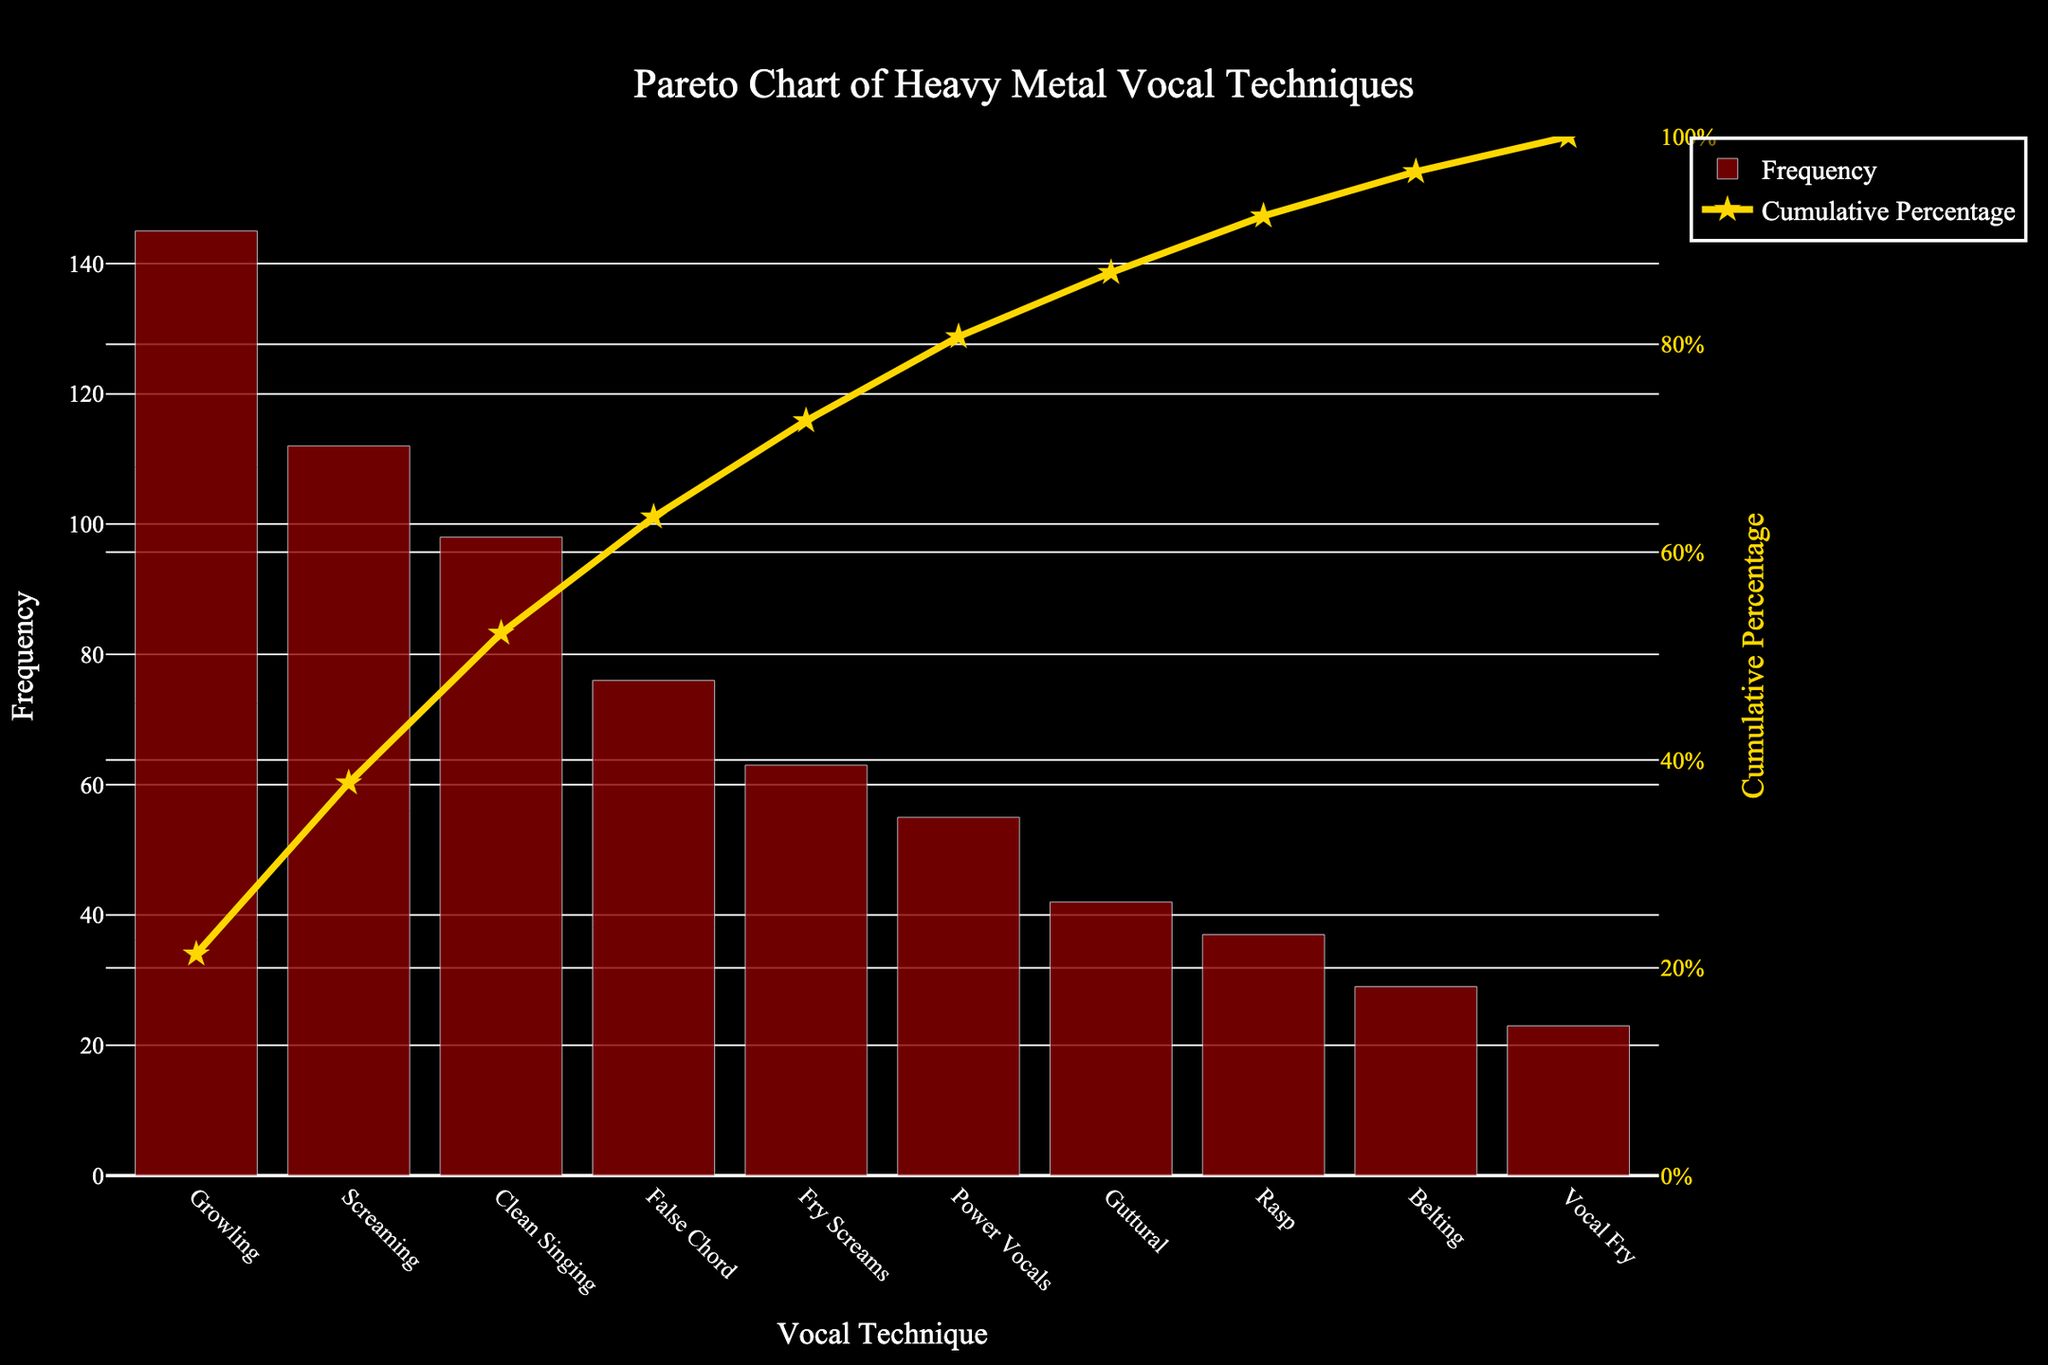What's the most frequently used vocal technique in heavy metal songs according to the chart? The bar with the highest frequency shows the Vocal Technique "Growling" at 145 occurrences, which makes it the most frequently used.
Answer: Growling What is the title of the chart? The chart title can be found at the top and reads "Pareto Chart of Heavy Metal Vocal Techniques".
Answer: Pareto Chart of Heavy Metal Vocal Techniques How many vocal techniques have a frequency higher than 100? By examining the bars, "Growling" and "Screaming" both have frequencies higher than 100 (145 and 112, respectively).
Answer: 2 Which vocal technique has the lowest frequency? The bar with the smallest height represents the "Vocal Fry" technique, with a frequency of 23.
Answer: Vocal Fry What's the cumulative percentage of the first three vocal techniques combined? Summing up the first three frequencies (145+112+98) gives 355. The total frequency is 680. So, 355/680 * 100 = 52.21%.
Answer: 52.21% Is the frequency of "False Chord" higher or lower than "Clean Singing"? "False Chord" has a frequency of 76 while "Clean Singing" has 98. Therefore, "False Chord" is lower.
Answer: Lower What is the color of the bar representing the frequency of each vocal technique? All the bars representing frequencies in the chart are colored dark red.
Answer: Dark Red Which vocal technique hits the 80% mark in the cumulative percentage curve? Following the cumulative percentage line up to the 80% mark corresponds with the "False Chord" technique.
Answer: False Chord By how many does the frequency of "Growling" exceed the frequency of "Guttural"? The frequency of "Growling" is 145 and for "Guttural," it is 42. So, the difference is 145 - 42 = 103.
Answer: 103 What is the cumulative percentage after adding up the frequencies of "Fry Screams," "Power Vocals," and "Guttural"? Adding the frequencies gives (63 + 55 + 42) = 160. The cumulative frequency up to "Guttural" is 98 + 76 + 63 + 55 + 42 = 334. To get the cumulative percentage: (334 / 680) * 100 = 49.12%.
Answer: 49.12% 